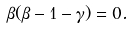Convert formula to latex. <formula><loc_0><loc_0><loc_500><loc_500>\beta ( \beta - 1 - \gamma ) = 0 .</formula> 